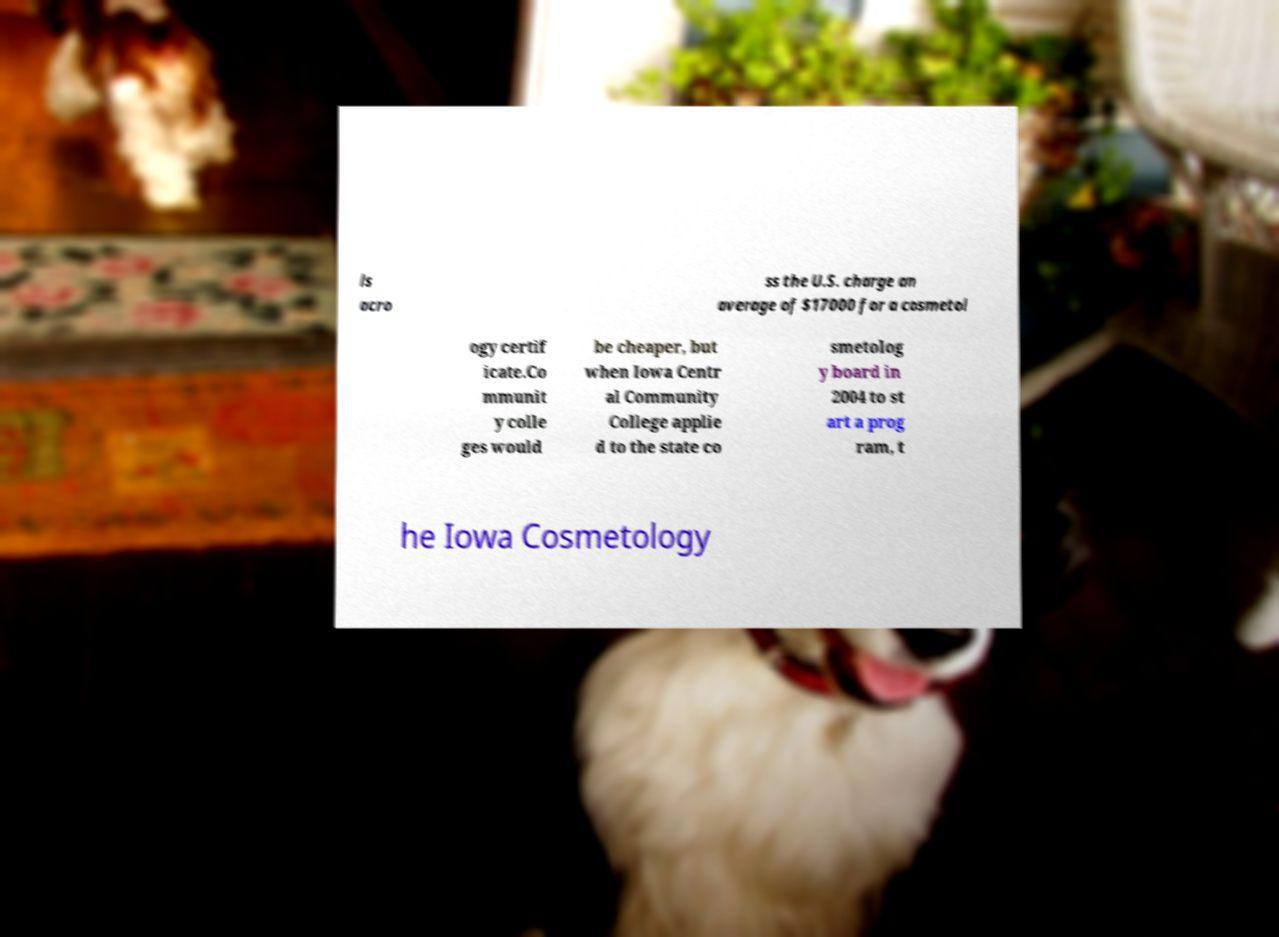What messages or text are displayed in this image? I need them in a readable, typed format. ls acro ss the U.S. charge an average of $17000 for a cosmetol ogy certif icate.Co mmunit y colle ges would be cheaper, but when Iowa Centr al Community College applie d to the state co smetolog y board in 2004 to st art a prog ram, t he Iowa Cosmetology 